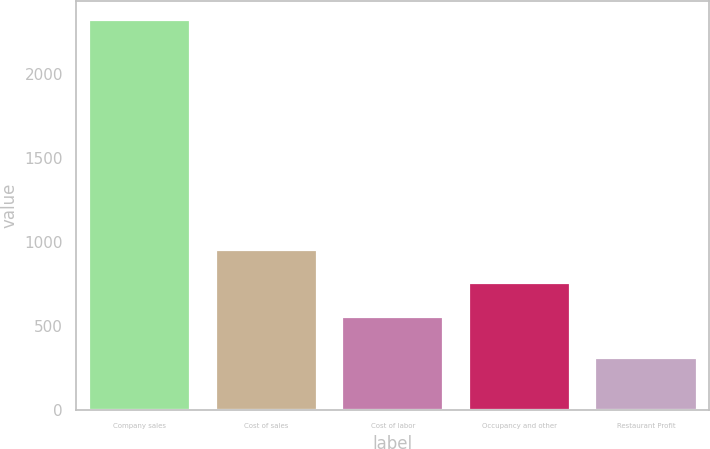Convert chart. <chart><loc_0><loc_0><loc_500><loc_500><bar_chart><fcel>Company sales<fcel>Cost of sales<fcel>Cost of labor<fcel>Occupancy and other<fcel>Restaurant Profit<nl><fcel>2320<fcel>954.4<fcel>552<fcel>753.2<fcel>308<nl></chart> 